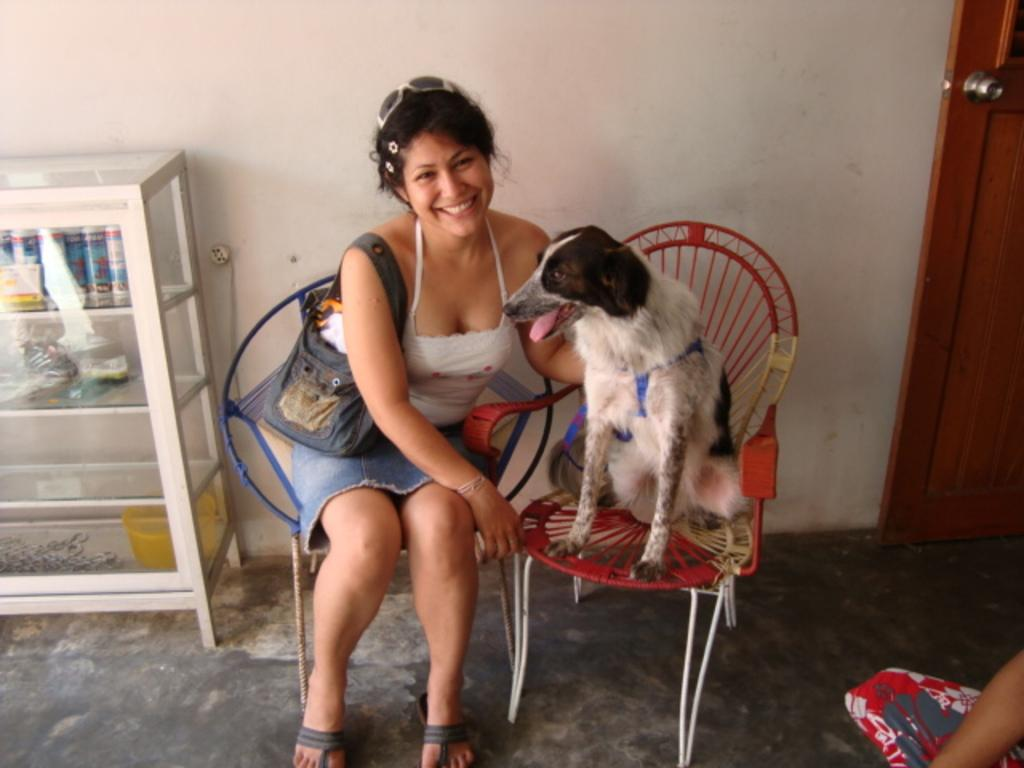Who is present in the image? There is a woman in the image. What other living creature is present in the image? There is a dog in the image. What are the woman and the dog doing in the image? Both the woman and the dog are sitting on chairs. What can be seen in the background of the image? There is a glass cupboard and a door in the background of the image. What type of rose can be seen in the image? There is no rose present in the image. How does the toad interact with the woman and the dog in the image? There is no toad present in the image. 